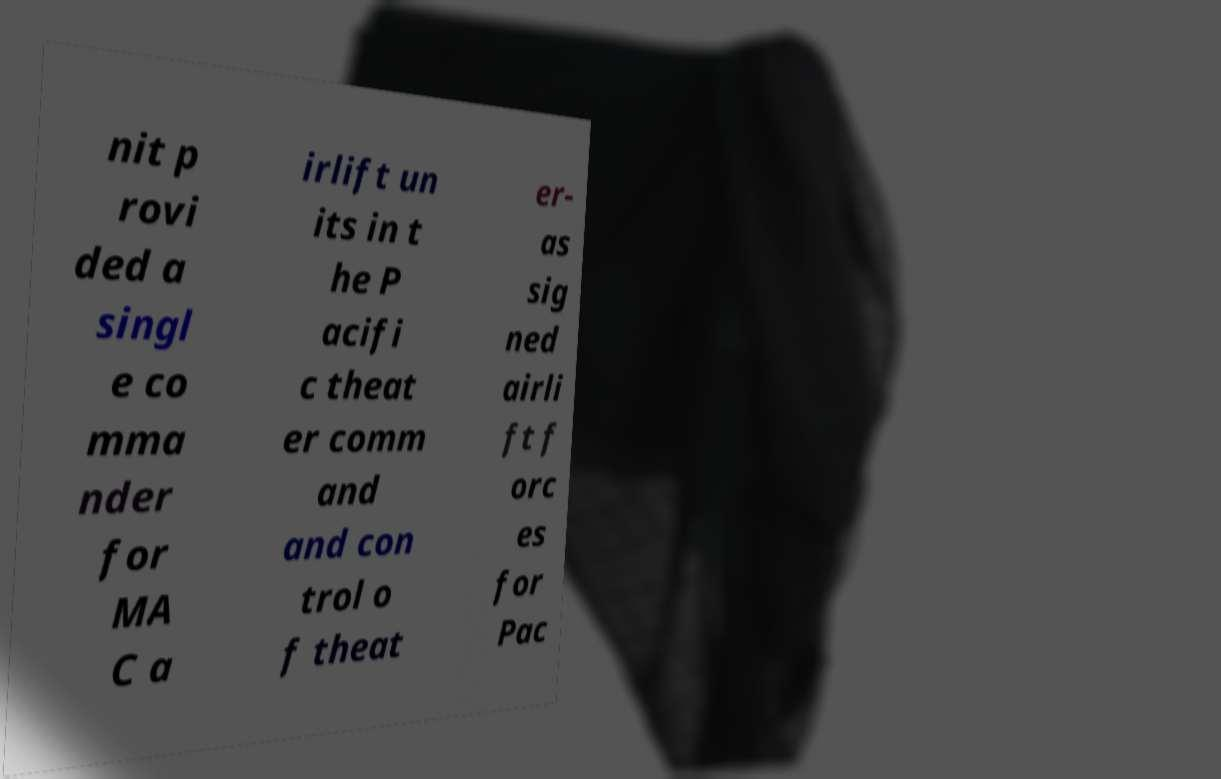Could you extract and type out the text from this image? nit p rovi ded a singl e co mma nder for MA C a irlift un its in t he P acifi c theat er comm and and con trol o f theat er- as sig ned airli ft f orc es for Pac 